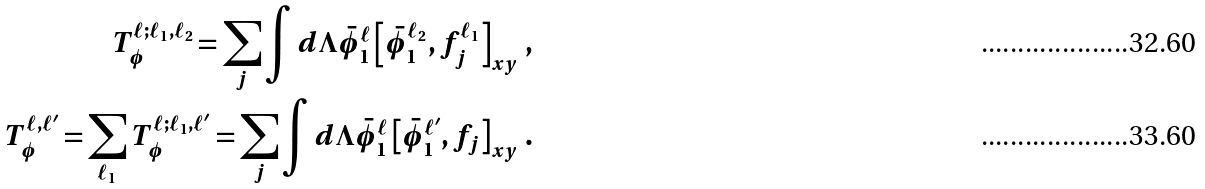<formula> <loc_0><loc_0><loc_500><loc_500>T _ { \phi } ^ { \ell ; \ell _ { 1 } , \ell _ { 2 } } = \sum _ { j } \int d \Lambda \bar { \phi } _ { 1 } ^ { \ell } \left [ \bar { \phi } _ { 1 } ^ { \ell _ { 2 } } , f _ { j } ^ { \ell _ { 1 } } \right ] _ { x y } \, , \\ T _ { \phi } ^ { \ell , \ell ^ { \prime } } = \sum _ { \ell _ { 1 } } T _ { \phi } ^ { \ell ; \ell _ { 1 } , \ell ^ { \prime } } = \sum _ { j } \int d \Lambda \bar { \phi } _ { 1 } ^ { \ell } \left [ \bar { \phi } _ { 1 } ^ { \ell ^ { \prime } } , f _ { j } \right ] _ { x y } \, .</formula> 